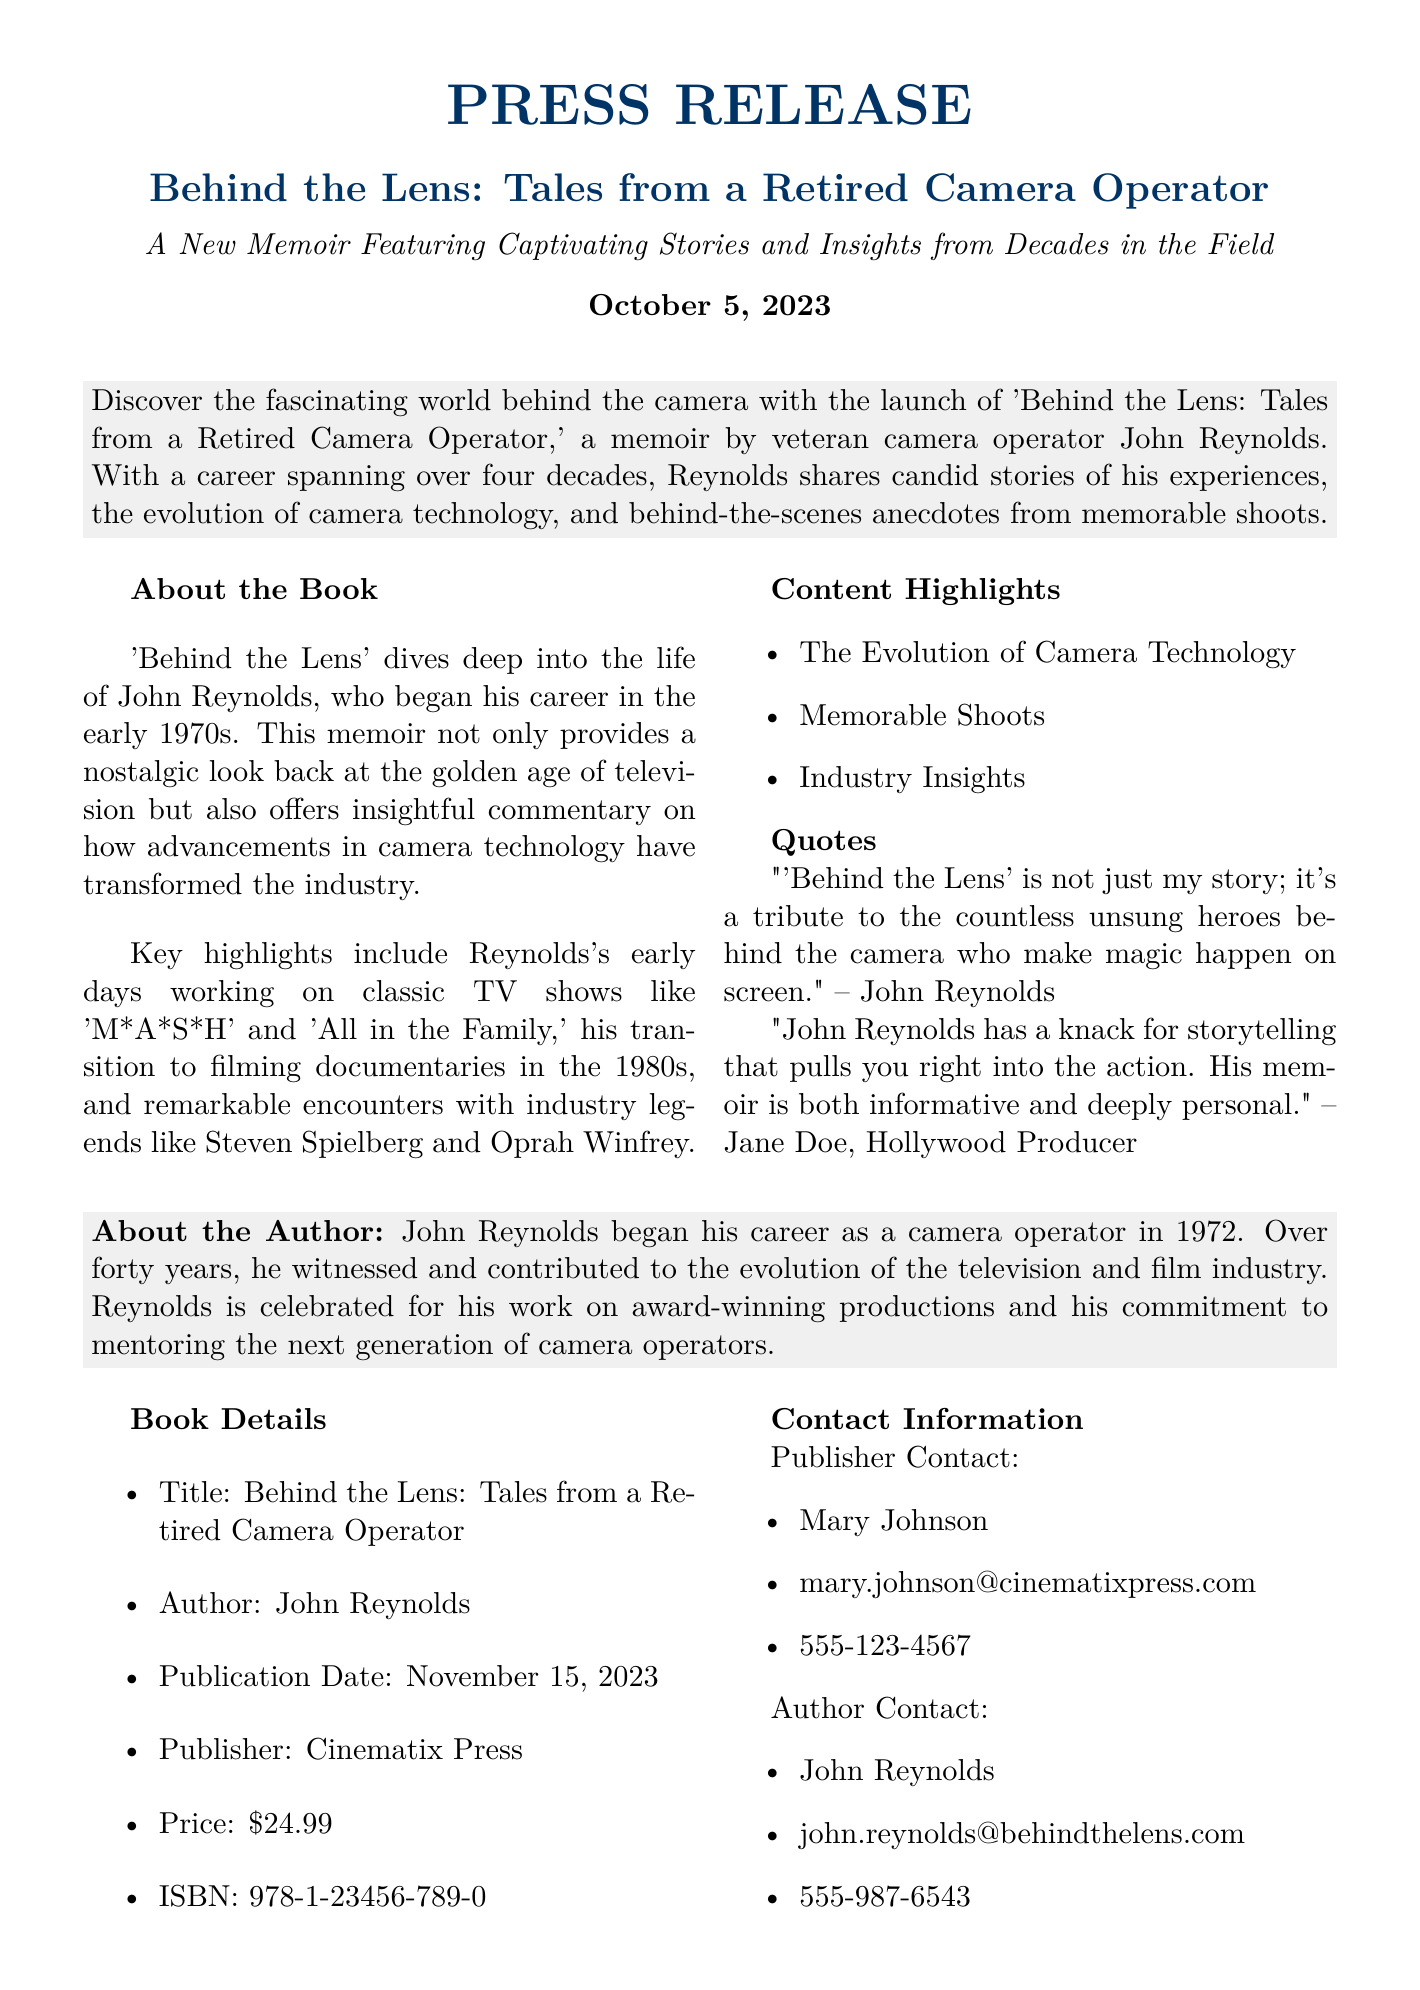What is the title of the book? The title of the book is presented at the top of the press release.
Answer: Behind the Lens: Tales from a Retired Camera Operator Who is the author of the book? The author is mentioned in the document as a veteran camera operator.
Answer: John Reynolds When is the publication date? The publication date is clearly stated in the book details section.
Answer: November 15, 2023 What is the price of the book? The price is listed under book details in the document.
Answer: $24.99 What significant TV shows does John Reynolds recount working on? The memoir discusses classic shows from the early career of the author.
Answer: M*A*S*H and All in the Family What does the author believe 'Behind the Lens' is a tribute to? The quote from John Reynolds indicates an aspect he honors through his memoir.
Answer: Unsung heroes behind the camera Which publisher is releasing the book? The publisher is identified in the book details.
Answer: Cinematix Press What is the ISBN of the book? The ISBN is provided in the book details section.
Answer: 978-1-23456-789-0 Who is the contact person for the publisher? The document includes contact information for the publisher.
Answer: Mary Johnson 